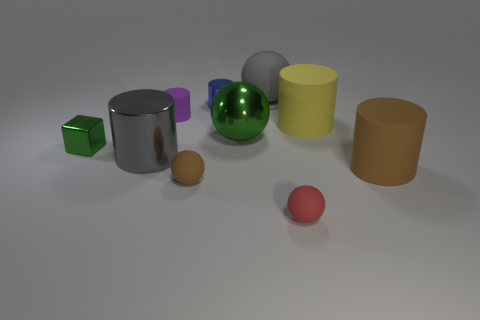Subtract all purple cylinders. How many cylinders are left? 4 Subtract 2 cylinders. How many cylinders are left? 3 Subtract all purple cylinders. How many cylinders are left? 4 Subtract all gray cylinders. Subtract all brown cubes. How many cylinders are left? 4 Subtract all spheres. How many objects are left? 6 Subtract 0 blue balls. How many objects are left? 10 Subtract all brown things. Subtract all tiny red matte balls. How many objects are left? 7 Add 3 gray matte things. How many gray matte things are left? 4 Add 4 large gray rubber cylinders. How many large gray rubber cylinders exist? 4 